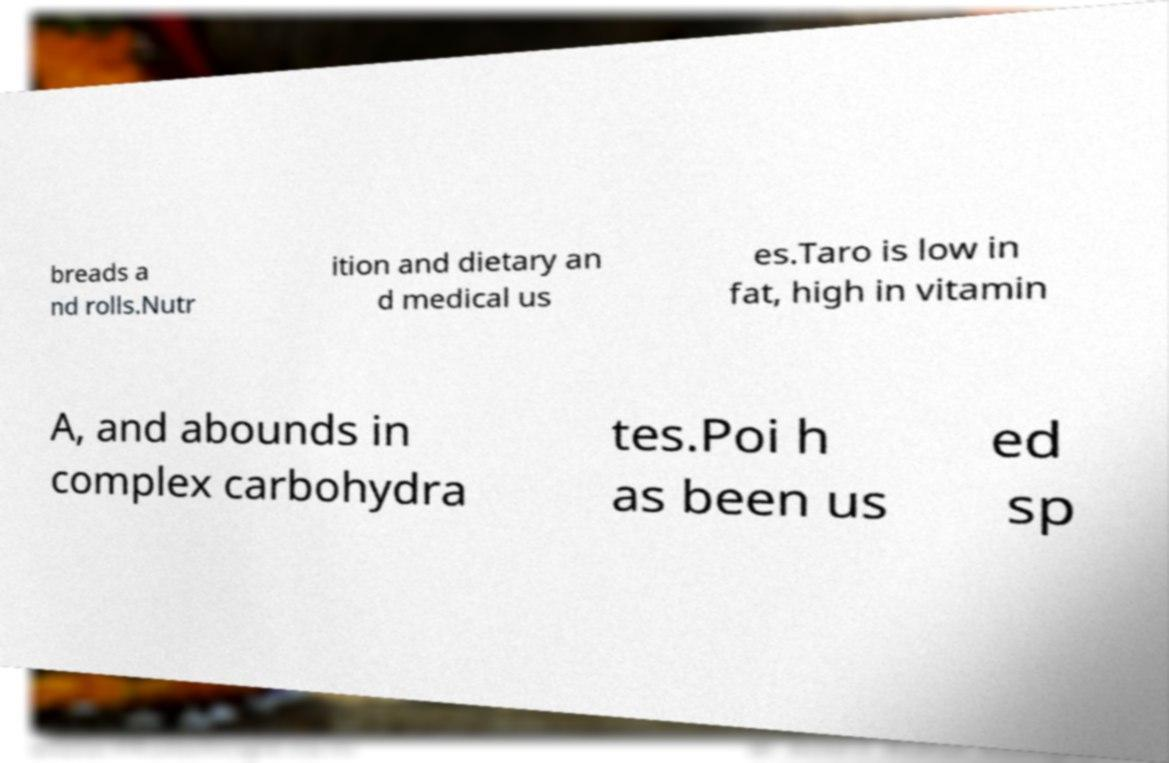What messages or text are displayed in this image? I need them in a readable, typed format. breads a nd rolls.Nutr ition and dietary an d medical us es.Taro is low in fat, high in vitamin A, and abounds in complex carbohydra tes.Poi h as been us ed sp 